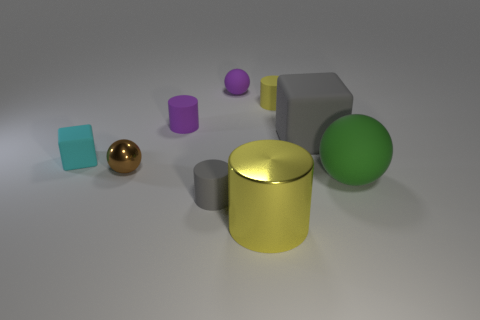What size is the rubber cylinder that is the same color as the big block?
Provide a succinct answer. Small. The gray thing that is to the left of the small sphere behind the metal thing to the left of the small purple cylinder is what shape?
Offer a very short reply. Cylinder. Do the cylinder in front of the tiny gray rubber object and the metallic object left of the purple sphere have the same color?
Provide a succinct answer. No. There is a tiny rubber thing that is the same color as the small matte sphere; what is its shape?
Provide a short and direct response. Cylinder. What number of shiny objects are red blocks or tiny gray cylinders?
Ensure brevity in your answer.  0. What color is the sphere that is right of the large rubber object that is behind the rubber thing that is to the right of the big gray rubber block?
Make the answer very short. Green. There is another thing that is the same shape as the large gray thing; what color is it?
Offer a terse response. Cyan. Is there anything else that is the same color as the tiny matte sphere?
Your answer should be compact. Yes. What number of other objects are the same material as the purple cylinder?
Your answer should be very brief. 6. The yellow matte cylinder is what size?
Ensure brevity in your answer.  Small. 